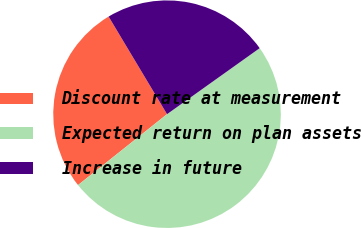<chart> <loc_0><loc_0><loc_500><loc_500><pie_chart><fcel>Discount rate at measurement<fcel>Expected return on plan assets<fcel>Increase in future<nl><fcel>27.12%<fcel>49.15%<fcel>23.73%<nl></chart> 